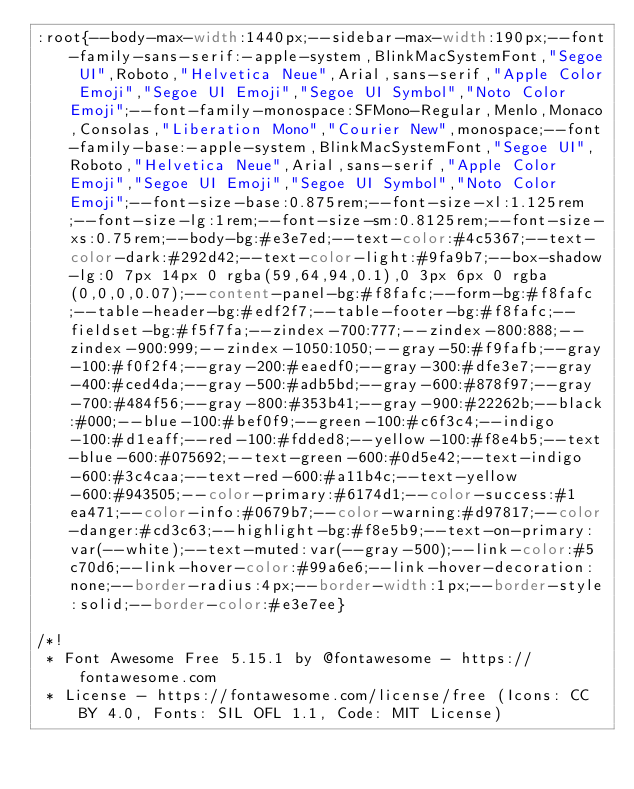<code> <loc_0><loc_0><loc_500><loc_500><_CSS_>:root{--body-max-width:1440px;--sidebar-max-width:190px;--font-family-sans-serif:-apple-system,BlinkMacSystemFont,"Segoe UI",Roboto,"Helvetica Neue",Arial,sans-serif,"Apple Color Emoji","Segoe UI Emoji","Segoe UI Symbol","Noto Color Emoji";--font-family-monospace:SFMono-Regular,Menlo,Monaco,Consolas,"Liberation Mono","Courier New",monospace;--font-family-base:-apple-system,BlinkMacSystemFont,"Segoe UI",Roboto,"Helvetica Neue",Arial,sans-serif,"Apple Color Emoji","Segoe UI Emoji","Segoe UI Symbol","Noto Color Emoji";--font-size-base:0.875rem;--font-size-xl:1.125rem;--font-size-lg:1rem;--font-size-sm:0.8125rem;--font-size-xs:0.75rem;--body-bg:#e3e7ed;--text-color:#4c5367;--text-color-dark:#292d42;--text-color-light:#9fa9b7;--box-shadow-lg:0 7px 14px 0 rgba(59,64,94,0.1),0 3px 6px 0 rgba(0,0,0,0.07);--content-panel-bg:#f8fafc;--form-bg:#f8fafc;--table-header-bg:#edf2f7;--table-footer-bg:#f8fafc;--fieldset-bg:#f5f7fa;--zindex-700:777;--zindex-800:888;--zindex-900:999;--zindex-1050:1050;--gray-50:#f9fafb;--gray-100:#f0f2f4;--gray-200:#eaedf0;--gray-300:#dfe3e7;--gray-400:#ced4da;--gray-500:#adb5bd;--gray-600:#878f97;--gray-700:#484f56;--gray-800:#353b41;--gray-900:#22262b;--black:#000;--blue-100:#bef0f9;--green-100:#c6f3c4;--indigo-100:#d1eaff;--red-100:#fdded8;--yellow-100:#f8e4b5;--text-blue-600:#075692;--text-green-600:#0d5e42;--text-indigo-600:#3c4caa;--text-red-600:#a11b4c;--text-yellow-600:#943505;--color-primary:#6174d1;--color-success:#1ea471;--color-info:#0679b7;--color-warning:#d97817;--color-danger:#cd3c63;--highlight-bg:#f8e5b9;--text-on-primary:var(--white);--text-muted:var(--gray-500);--link-color:#5c70d6;--link-hover-color:#99a6e6;--link-hover-decoration:none;--border-radius:4px;--border-width:1px;--border-style:solid;--border-color:#e3e7ee}

/*!
 * Font Awesome Free 5.15.1 by @fontawesome - https://fontawesome.com
 * License - https://fontawesome.com/license/free (Icons: CC BY 4.0, Fonts: SIL OFL 1.1, Code: MIT License)</code> 